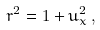Convert formula to latex. <formula><loc_0><loc_0><loc_500><loc_500>r ^ { 2 } = 1 + u _ { x } ^ { 2 } \, ,</formula> 